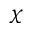Convert formula to latex. <formula><loc_0><loc_0><loc_500><loc_500>\chi</formula> 